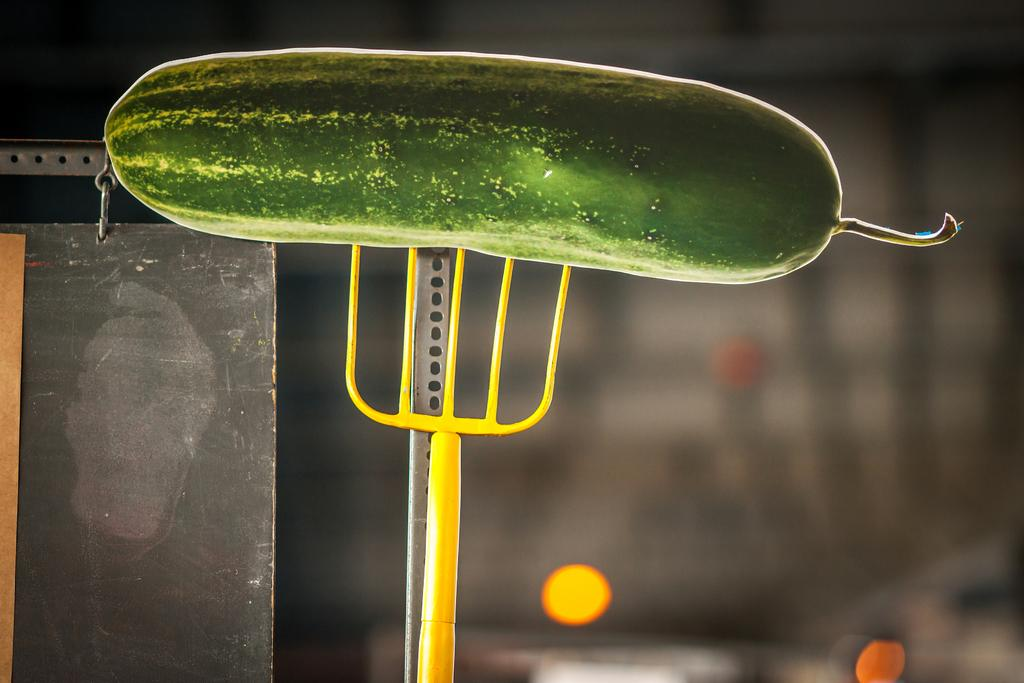What is the main object in the foreground of the image? There is a cucumber-like object in the foreground of the image. What other object is present in the foreground of the image? There is a fork-like object in the foreground of the image. Can you describe the object on the left side of the image? There is a metal object on the left side of the image. How would you describe the background of the image? The background of the image is blurred. What type of earthquake is mentioned in the caption of the image? There is no caption present in the image, and therefore no earthquake information can be found. 